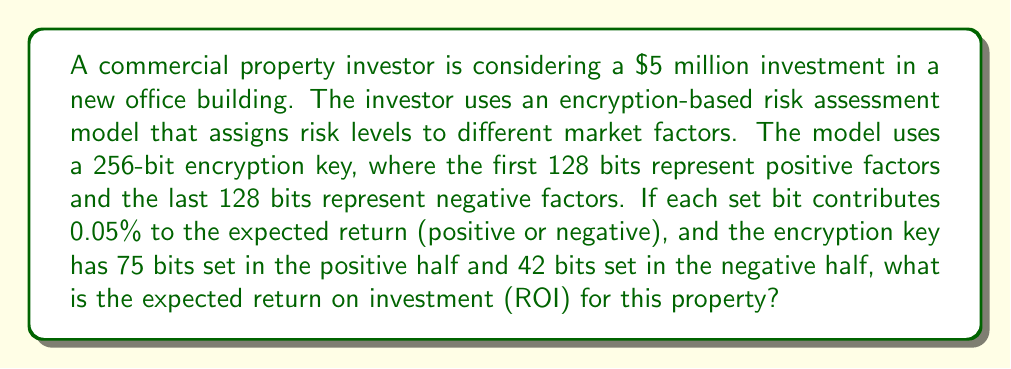Provide a solution to this math problem. To calculate the expected return on investment using the encryption-based risk assessment model, we need to follow these steps:

1. Calculate the positive contribution:
   Number of positive bits set = 75
   Contribution per bit = 0.05%
   Positive contribution = $75 \times 0.05\% = 3.75\%$

2. Calculate the negative contribution:
   Number of negative bits set = 42
   Contribution per bit = 0.05%
   Negative contribution = $42 \times 0.05\% = 2.10\%$

3. Calculate the net expected return:
   Net expected return = Positive contribution - Negative contribution
   $Net expected return = 3.75\% - 2.10\% = 1.65\%$

4. Calculate the expected return on investment (ROI):
   Initial investment = $5,000,000
   Expected return = $5,000,000 \times 1.65\% = $82,500$
   
   ROI = $\frac{\text{Expected Return}}{\text{Initial Investment}} \times 100\%$
   
   $$ROI = \frac{82,500}{5,000,000} \times 100\% = 1.65\%$$

Therefore, the expected return on investment (ROI) for this property is 1.65%.
Answer: 1.65% 